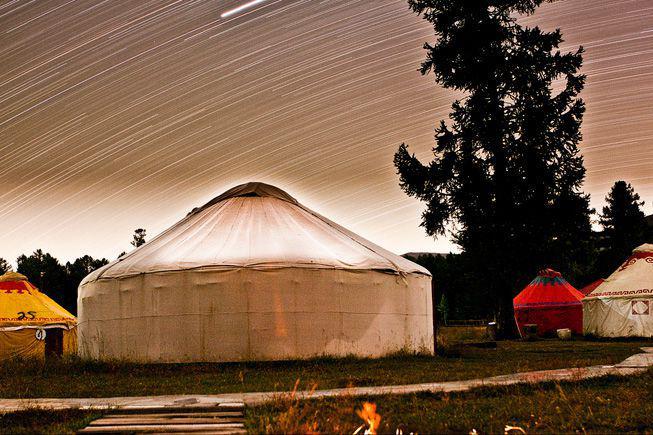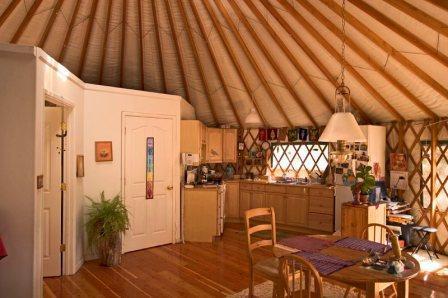The first image is the image on the left, the second image is the image on the right. Evaluate the accuracy of this statement regarding the images: "In one image, at least four yurts are seen in an outdoor area with at least one tree, while a second image shows the interior of a yurt with lattice on wall area.". Is it true? Answer yes or no. Yes. The first image is the image on the left, the second image is the image on the right. Examine the images to the left and right. Is the description "One image is an interior with lattice on the walls, and the other is an exterior shot of round buildings with a tall tree present." accurate? Answer yes or no. Yes. 